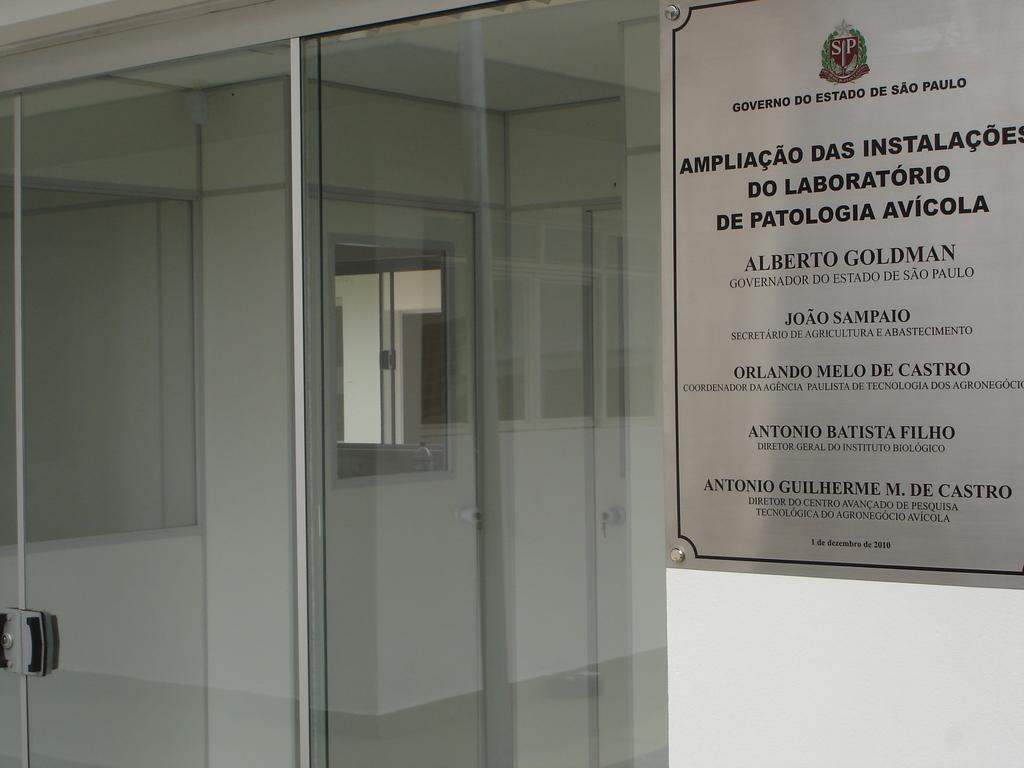<image>
Describe the image concisely. a sign on a wall that says apliacao das instalacoes' on it 